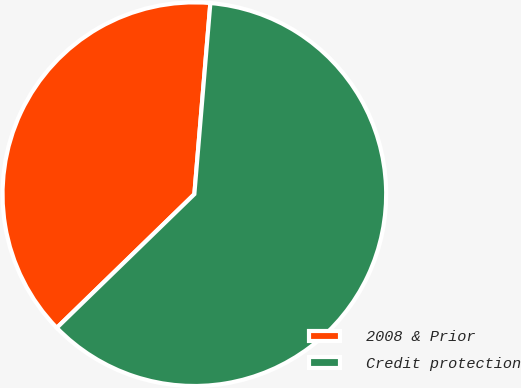Convert chart. <chart><loc_0><loc_0><loc_500><loc_500><pie_chart><fcel>2008 & Prior<fcel>Credit protection<nl><fcel>38.6%<fcel>61.4%<nl></chart> 